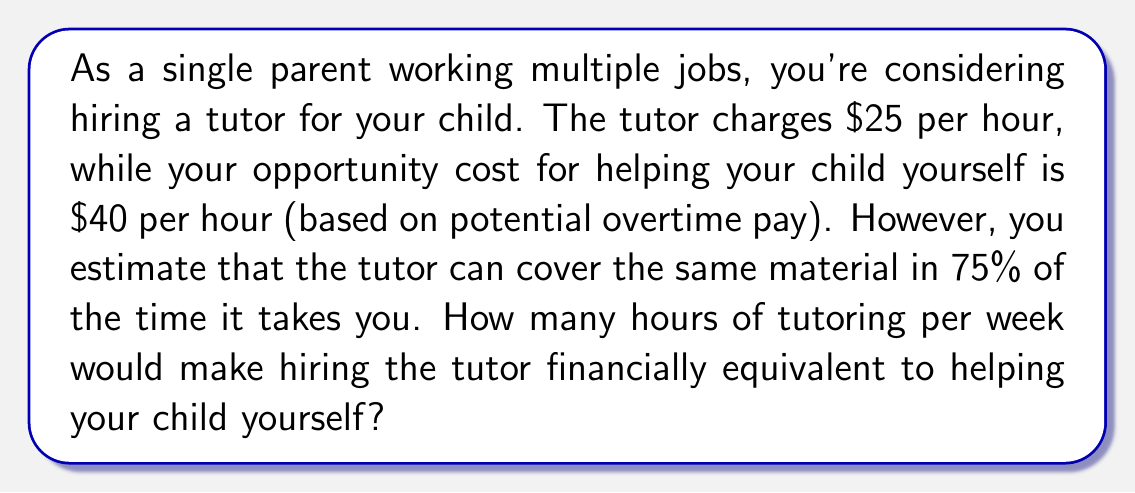Teach me how to tackle this problem. Let's approach this step-by-step:

1) Let $x$ be the number of hours the tutor spends with your child per week.

2) The cost of hiring the tutor for $x$ hours is:
   $$25x$$

3) If the tutor can cover the same material in 75% of the time it takes you, then you would need to spend $\frac{x}{0.75}$ hours to cover the same material.

4) Your opportunity cost for this time would be:
   $$40 \cdot \frac{x}{0.75} = \frac{160x}{3}$$

5) The break-even point occurs when these two costs are equal:
   $$25x = \frac{160x}{3}$$

6) Solving this equation:
   $$75x = 160x$$
   $$-85x = 0$$
   $$x = 0$$

7) This result indicates that the break-even point is at 0 hours, meaning hiring the tutor is always more cost-effective.

8) To find a meaningful break-even point, we need to consider a minimum number of hours, say 1 hour per week. 

9) For 1 hour of tutoring:
   Tutor cost: $25 * 1 = $25
   Your opportunity cost: $40 * (1/0.75) = $53.33

10) The difference in savings per hour of tutoring is:
    $$53.33 - 25 = $28.33$$
Answer: 0 hours; hiring the tutor is always more cost-effective, saving $28.33 per hour of tutoring. 